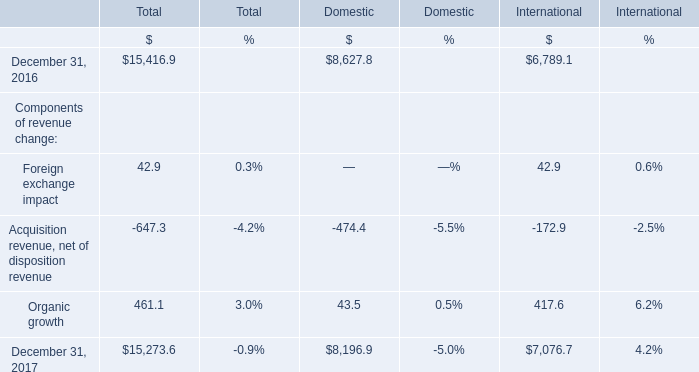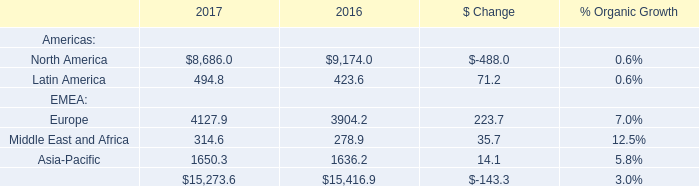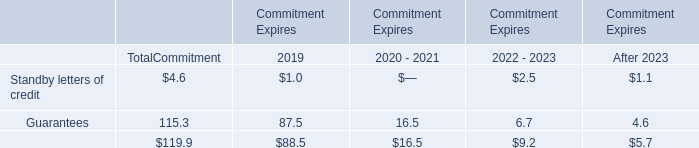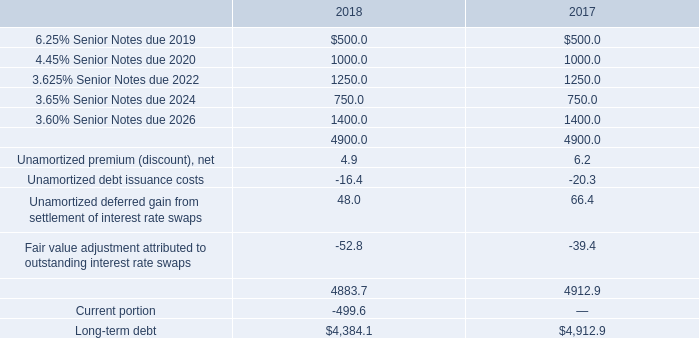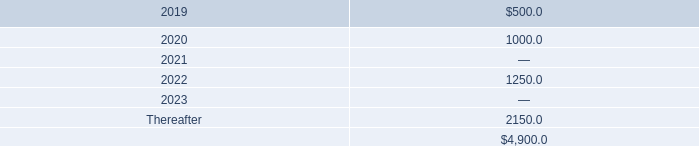What will components of revenue reach in 2018 if it continues to grow at its current rate? 
Computations: ((((15273.6 - 15416.9) / 15416.9) + 1) * 15273.6)
Answer: 15131.63197. 